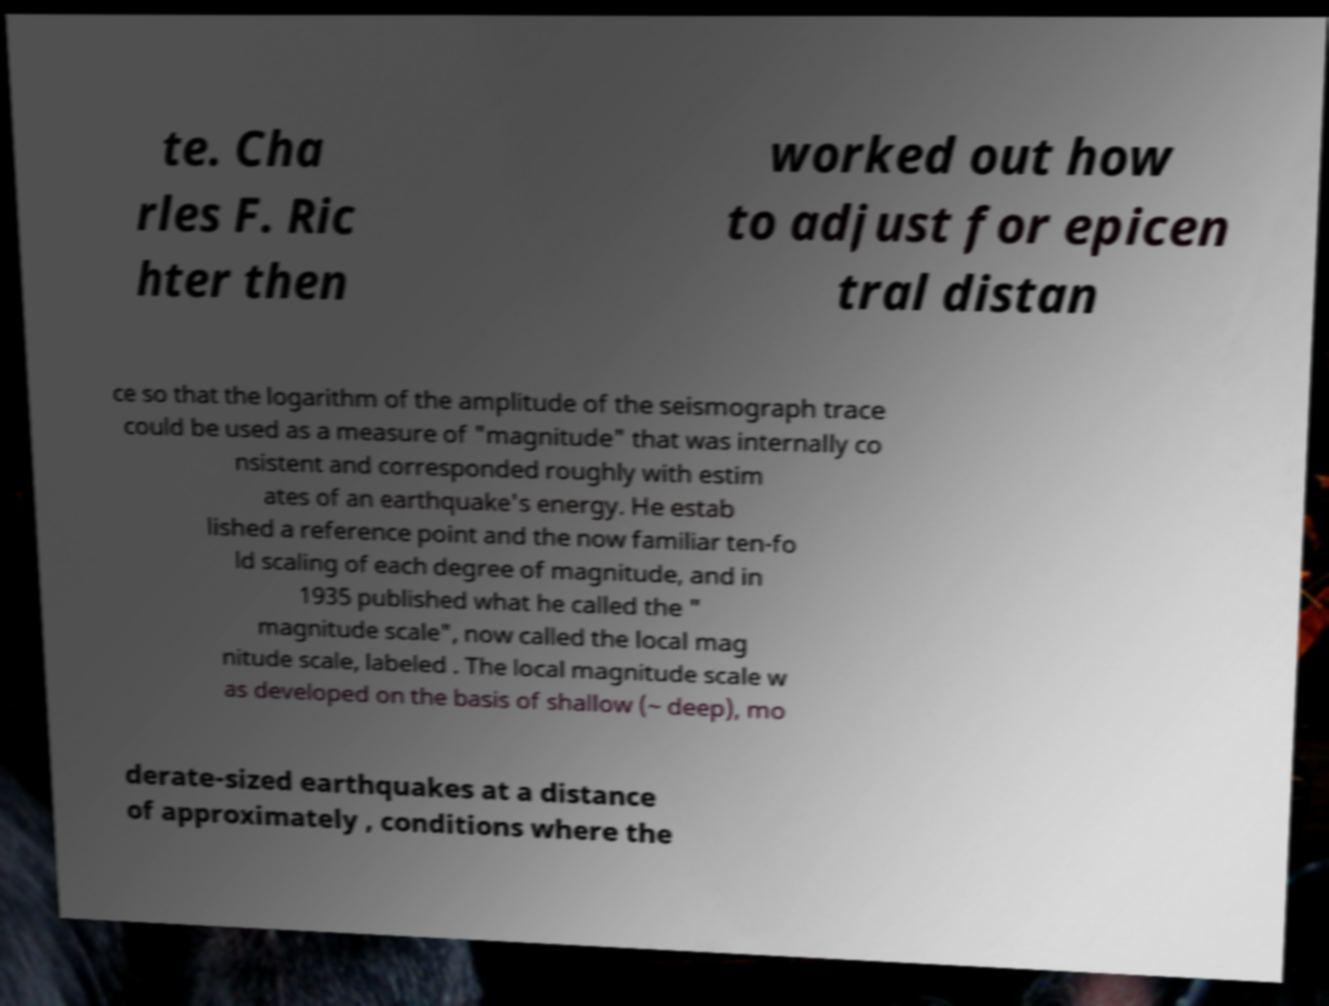Could you extract and type out the text from this image? te. Cha rles F. Ric hter then worked out how to adjust for epicen tral distan ce so that the logarithm of the amplitude of the seismograph trace could be used as a measure of "magnitude" that was internally co nsistent and corresponded roughly with estim ates of an earthquake's energy. He estab lished a reference point and the now familiar ten-fo ld scaling of each degree of magnitude, and in 1935 published what he called the " magnitude scale", now called the local mag nitude scale, labeled . The local magnitude scale w as developed on the basis of shallow (~ deep), mo derate-sized earthquakes at a distance of approximately , conditions where the 